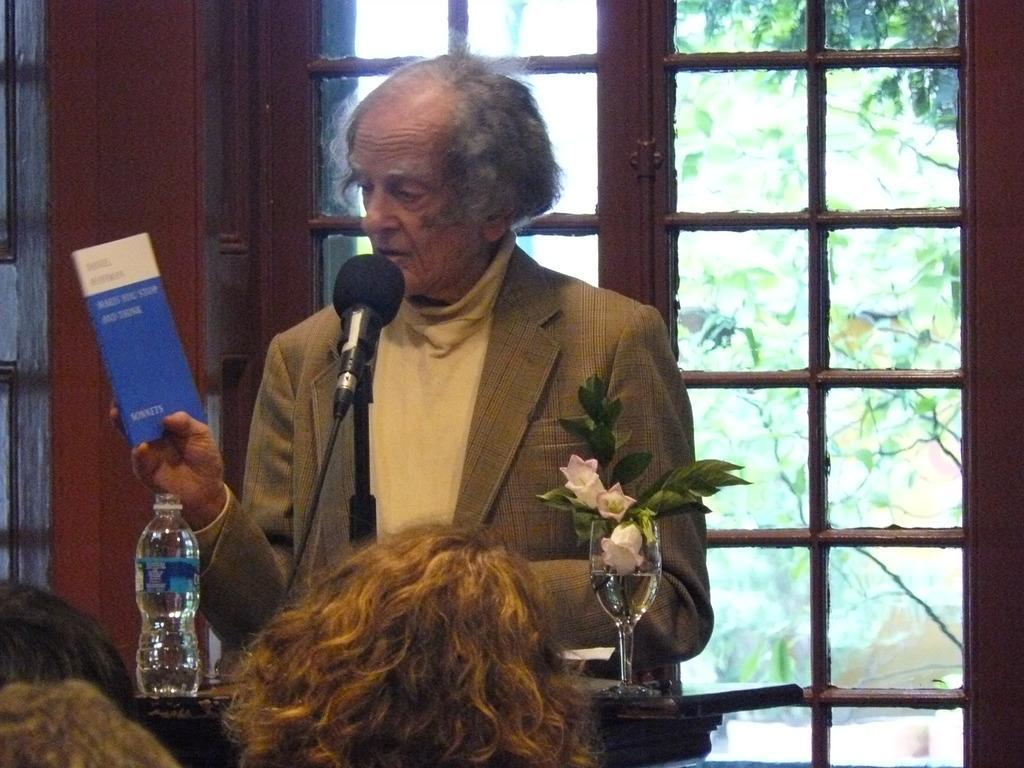Please provide a concise description of this image. In this image, human is standing in-front of microphone. He holds a book. Here there is a flower vase. On the right side of the man, we can see a bottle. In the bottom of the image, we can found few human heads. Background, there is a wooden door, some trees we can see. 